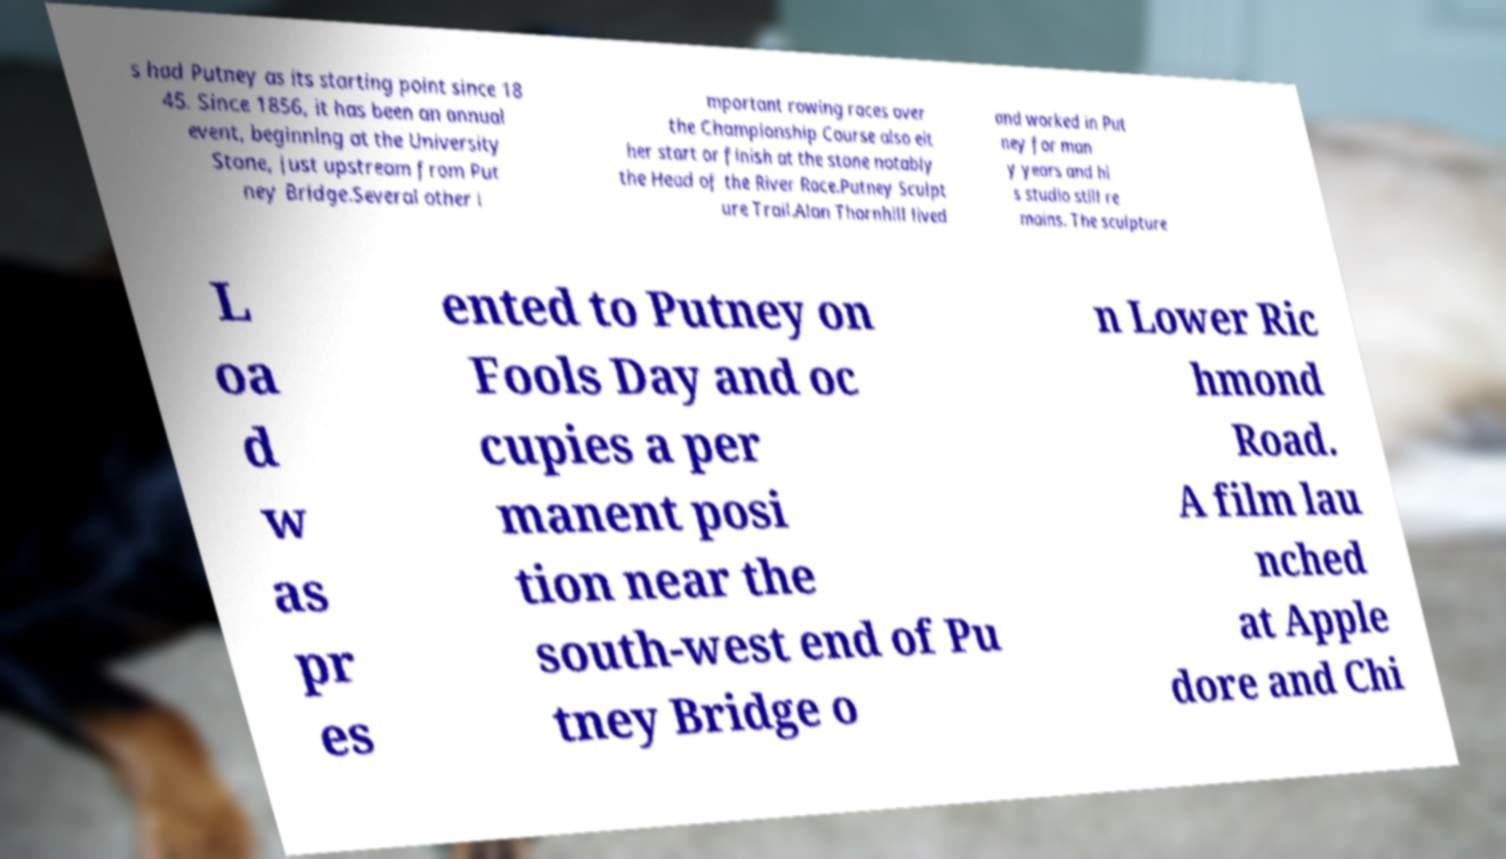Can you read and provide the text displayed in the image?This photo seems to have some interesting text. Can you extract and type it out for me? s had Putney as its starting point since 18 45. Since 1856, it has been an annual event, beginning at the University Stone, just upstream from Put ney Bridge.Several other i mportant rowing races over the Championship Course also eit her start or finish at the stone notably the Head of the River Race.Putney Sculpt ure Trail.Alan Thornhill lived and worked in Put ney for man y years and hi s studio still re mains. The sculpture L oa d w as pr es ented to Putney on Fools Day and oc cupies a per manent posi tion near the south-west end of Pu tney Bridge o n Lower Ric hmond Road. A film lau nched at Apple dore and Chi 